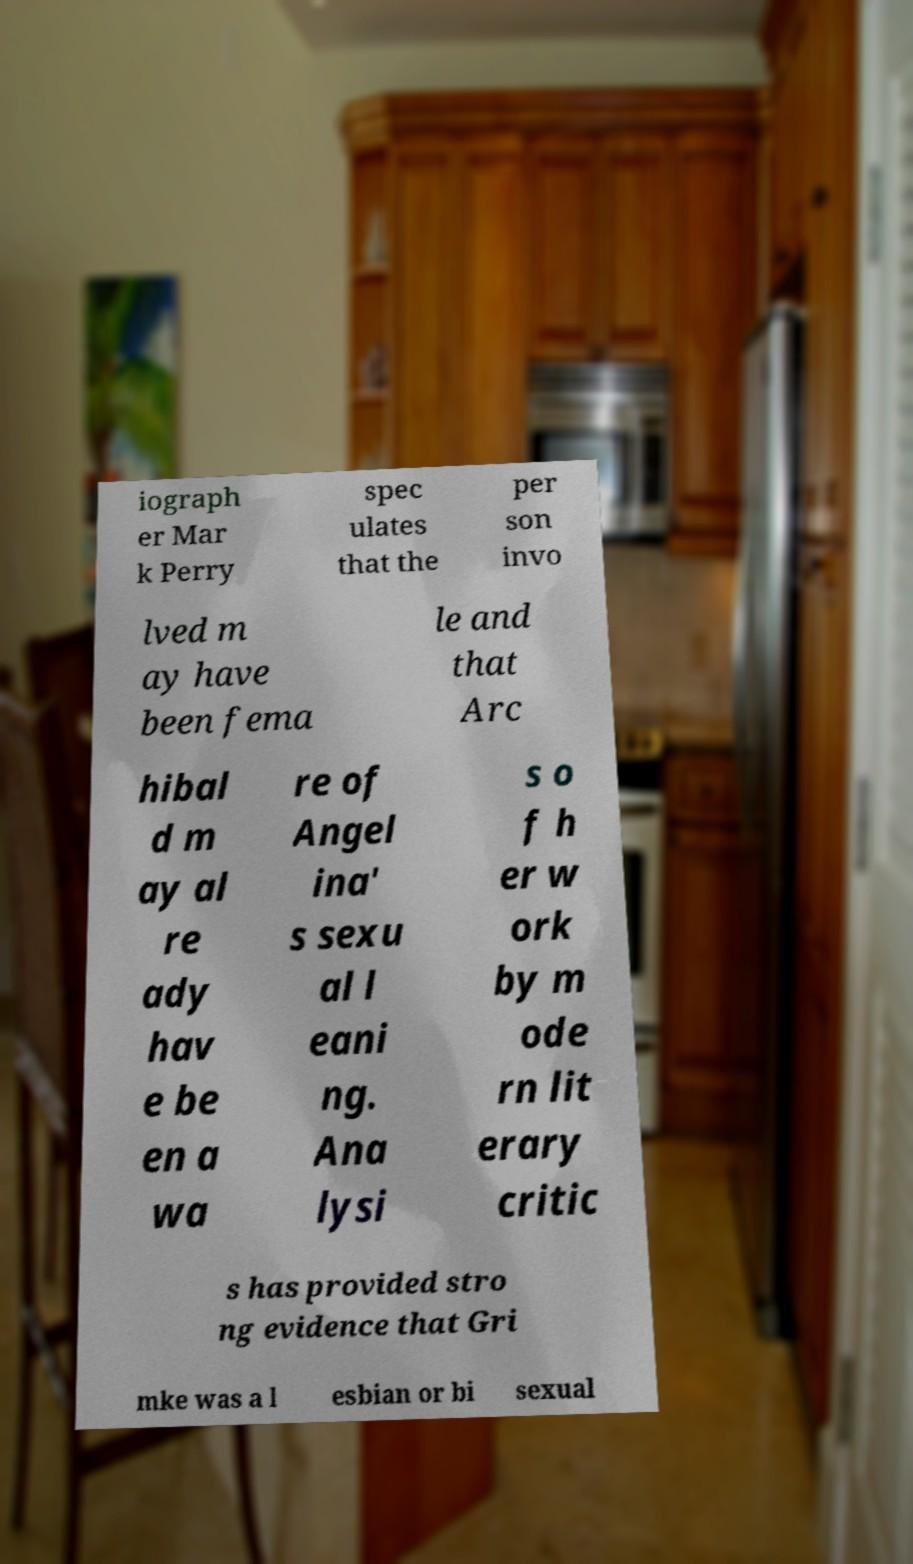Please read and relay the text visible in this image. What does it say? iograph er Mar k Perry spec ulates that the per son invo lved m ay have been fema le and that Arc hibal d m ay al re ady hav e be en a wa re of Angel ina' s sexu al l eani ng. Ana lysi s o f h er w ork by m ode rn lit erary critic s has provided stro ng evidence that Gri mke was a l esbian or bi sexual 